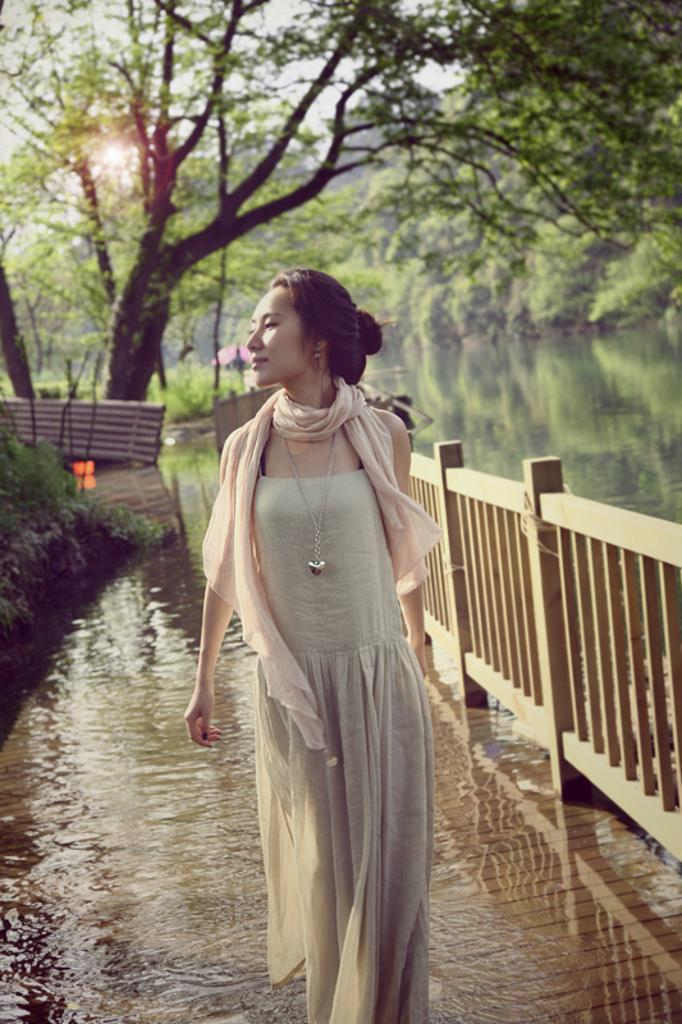What is the woman in the image doing? The woman is walking in the image. Where is the woman walking? The woman is on a bridge. What can be seen on the left side of the image? There is water and grass visible on the left side of the image. What is visible in the background of the image? There are trees and the sky visible in the background of the image, as well as water. What is the weight of the vest worn by the woman in the image? There is no vest visible in the image, so it is not possible to determine the weight of a vest. 